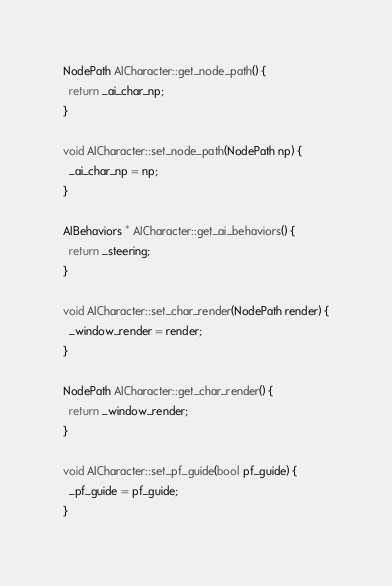<code> <loc_0><loc_0><loc_500><loc_500><_C++_>
NodePath AICharacter::get_node_path() {
  return _ai_char_np;
}

void AICharacter::set_node_path(NodePath np) {
  _ai_char_np = np;
}

AIBehaviors * AICharacter::get_ai_behaviors() {
  return _steering;
}

void AICharacter::set_char_render(NodePath render) {
  _window_render = render;
}

NodePath AICharacter::get_char_render() {
  return _window_render;
}

void AICharacter::set_pf_guide(bool pf_guide) {
  _pf_guide = pf_guide;
}
</code> 